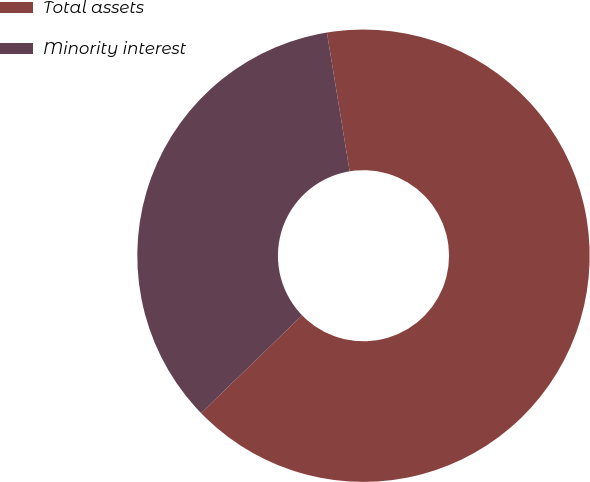Convert chart to OTSL. <chart><loc_0><loc_0><loc_500><loc_500><pie_chart><fcel>Total assets<fcel>Minority interest<nl><fcel>65.33%<fcel>34.67%<nl></chart> 